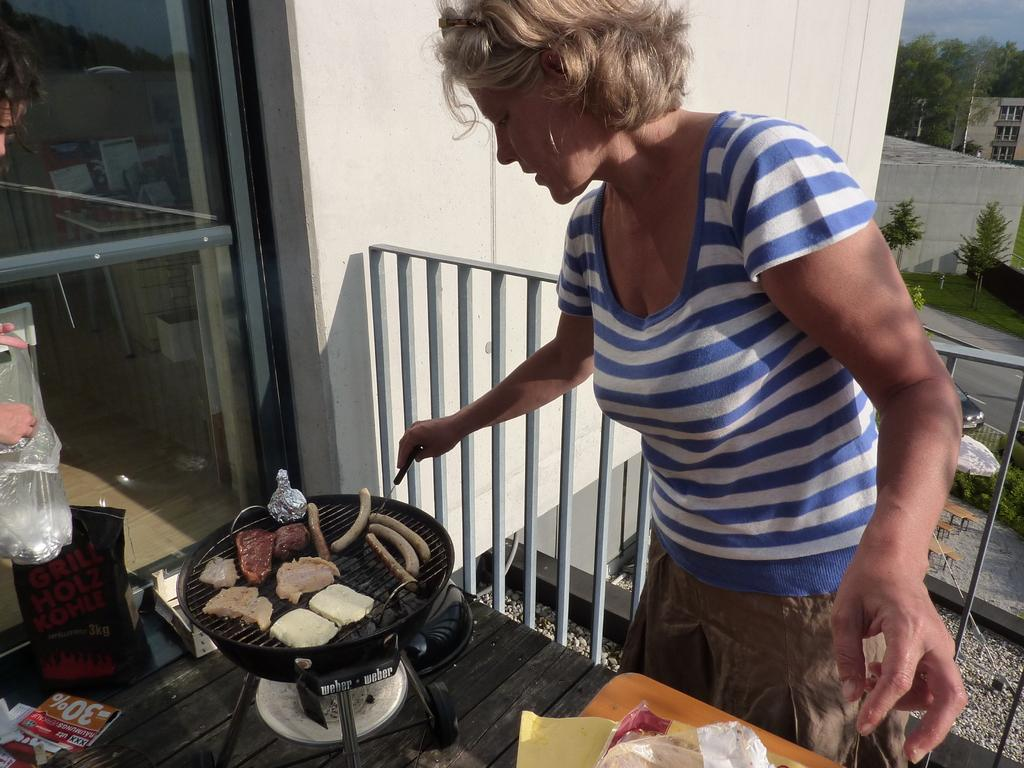<image>
Write a terse but informative summary of the picture. A woman cooks food on a grill that is next to a -30% tag. 